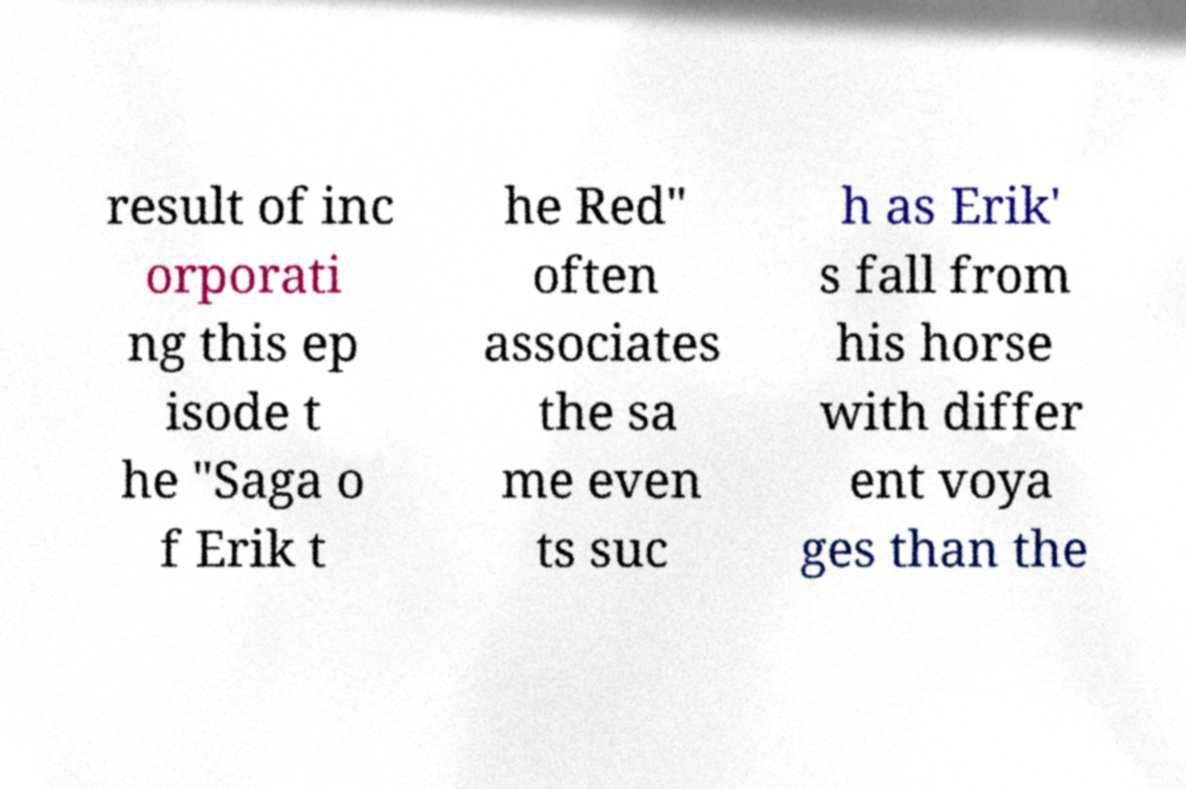What messages or text are displayed in this image? I need them in a readable, typed format. result of inc orporati ng this ep isode t he "Saga o f Erik t he Red" often associates the sa me even ts suc h as Erik' s fall from his horse with differ ent voya ges than the 